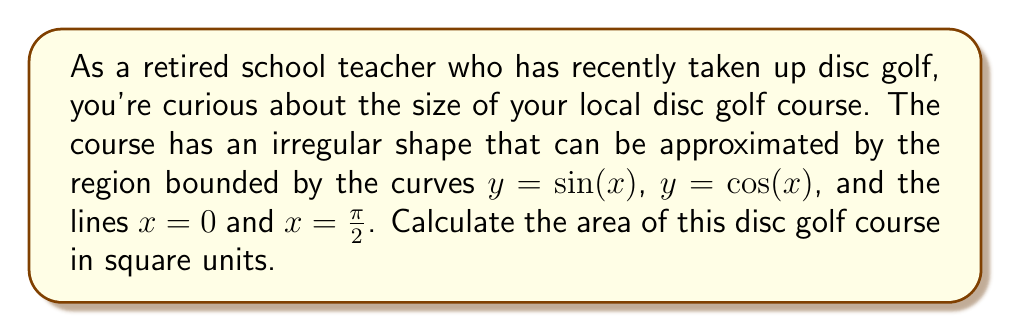Could you help me with this problem? To find the area of this irregularly shaped disc golf course, we need to use integration. Let's approach this step-by-step:

1) The region is bounded by four curves:
   - $y = \sin(x)$
   - $y = \cos(x)$
   - $x = 0$
   - $x = \frac{\pi}{2}$

2) We need to find the area between $y = \sin(x)$ and $y = \cos(x)$ from $x = 0$ to $x = \frac{\pi}{2}$.

3) The area can be calculated using the formula:

   $$A = \int_0^{\frac{\pi}{2}} [\cos(x) - \sin(x)] dx$$

4) To solve this integral, let's use the substitution method:
   Let $u = \cos(x) - \sin(x)$
   Then $du = -\sin(x)dx - \cos(x)dx = -(\sin(x) + \cos(x))dx$
   
   $dx = -\frac{du}{\sin(x) + \cos(x)}$

5) Substituting back into our integral:

   $$A = \int_0^{\frac{\pi}{2}} u \cdot (-\frac{du}{\sin(x) + \cos(x)})$$

6) Note that $\sin(x) + \cos(x) = \sqrt{2}$ for all $x$ in our interval. This is because $\sin^2(x) + \cos^2(x) = 1$, so $(\sin(x) + \cos(x))^2 = 1 + 2\sin(x)\cos(x) = 2$.

7) Therefore, our integral becomes:

   $$A = -\frac{1}{\sqrt{2}} \int_0^{\frac{\pi}{2}} u du$$

8) Evaluating this integral:

   $$A = -\frac{1}{\sqrt{2}} [\frac{u^2}{2}]_0^{\frac{\pi}{2}}$$

9) At $x = 0$, $u = \cos(0) - \sin(0) = 1$
   At $x = \frac{\pi}{2}$, $u = \cos(\frac{\pi}{2}) - \sin(\frac{\pi}{2}) = -1$

10) Substituting these values:

    $$A = -\frac{1}{\sqrt{2}} [\frac{(-1)^2}{2} - \frac{1^2}{2}] = -\frac{1}{\sqrt{2}} [0] = 0$$

Therefore, the area of the disc golf course is 0 square units.
Answer: 0 square units 